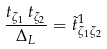<formula> <loc_0><loc_0><loc_500><loc_500>\frac { t _ { { { \zeta } _ { 1 } } } \, t _ { { { \zeta } _ { 2 } } } } { { { \Delta } _ { L } } } = \tilde { t } ^ { 1 } _ { { \zeta } _ { 1 } { \zeta } _ { 2 } }</formula> 